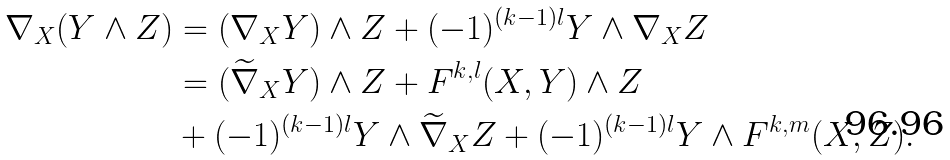<formula> <loc_0><loc_0><loc_500><loc_500>\nabla _ { X } ( Y \wedge Z ) & = ( \nabla _ { X } Y ) \wedge Z + ( - 1 ) ^ { ( k - 1 ) l } Y \wedge \nabla _ { X } Z \\ & = ( \widetilde { \nabla } _ { X } Y ) \wedge Z + F ^ { k , l } ( X , Y ) \wedge Z \\ & + ( - 1 ) ^ { ( k - 1 ) l } Y \wedge \widetilde { \nabla } _ { X } Z + ( - 1 ) ^ { ( k - 1 ) l } Y \wedge F ^ { k , m } ( X , Z ) .</formula> 